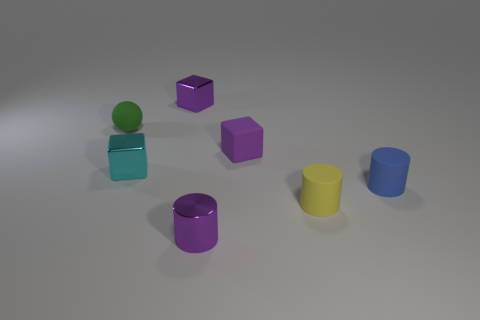Subtract all small metallic cubes. How many cubes are left? 1 Add 2 large yellow matte objects. How many objects exist? 9 Subtract 3 cylinders. How many cylinders are left? 0 Subtract all cyan cubes. How many cubes are left? 2 Subtract all balls. How many objects are left? 6 Subtract 0 green cubes. How many objects are left? 7 Subtract all brown cubes. Subtract all yellow cylinders. How many cubes are left? 3 Subtract all cyan blocks. How many green cylinders are left? 0 Subtract all large green blocks. Subtract all cyan metal blocks. How many objects are left? 6 Add 6 tiny purple shiny blocks. How many tiny purple shiny blocks are left? 7 